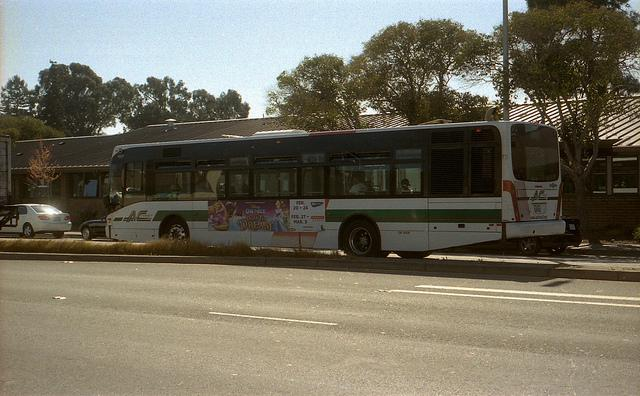What is the bus driving in?

Choices:
A) freeway
B) emergency lane
C) hov lane
D) middle lane hov lane 